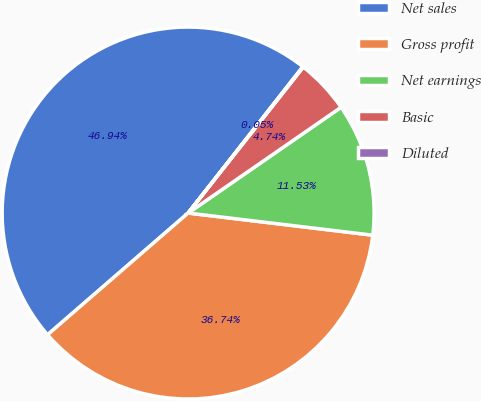Convert chart. <chart><loc_0><loc_0><loc_500><loc_500><pie_chart><fcel>Net sales<fcel>Gross profit<fcel>Net earnings<fcel>Basic<fcel>Diluted<nl><fcel>46.94%<fcel>36.74%<fcel>11.53%<fcel>4.74%<fcel>0.05%<nl></chart> 